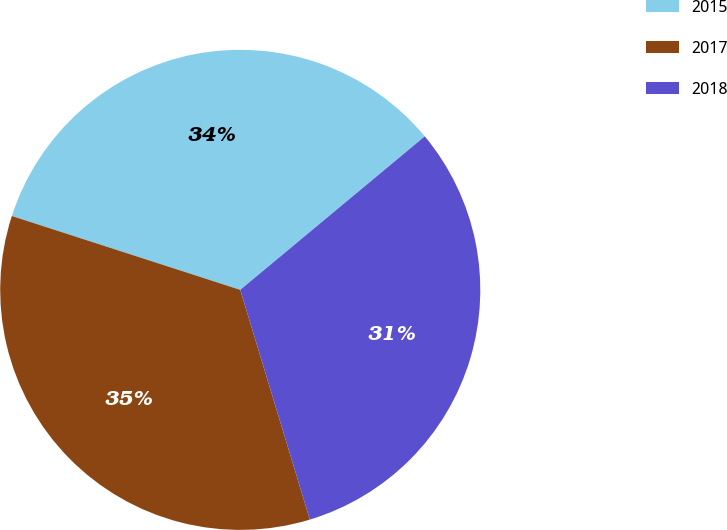Convert chart. <chart><loc_0><loc_0><loc_500><loc_500><pie_chart><fcel>2015<fcel>2017<fcel>2018<nl><fcel>33.98%<fcel>34.66%<fcel>31.36%<nl></chart> 